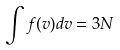<formula> <loc_0><loc_0><loc_500><loc_500>\int f ( v ) d v = 3 N</formula> 